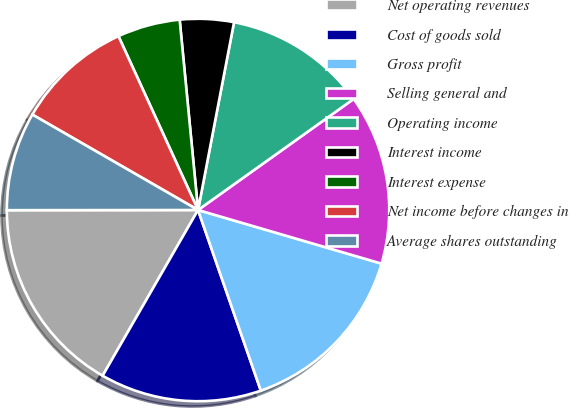<chart> <loc_0><loc_0><loc_500><loc_500><pie_chart><fcel>Net operating revenues<fcel>Cost of goods sold<fcel>Gross profit<fcel>Selling general and<fcel>Operating income<fcel>Interest income<fcel>Interest expense<fcel>Net income before changes in<fcel>Average shares outstanding<nl><fcel>16.67%<fcel>13.64%<fcel>15.15%<fcel>14.39%<fcel>12.12%<fcel>4.55%<fcel>5.3%<fcel>9.85%<fcel>8.33%<nl></chart> 